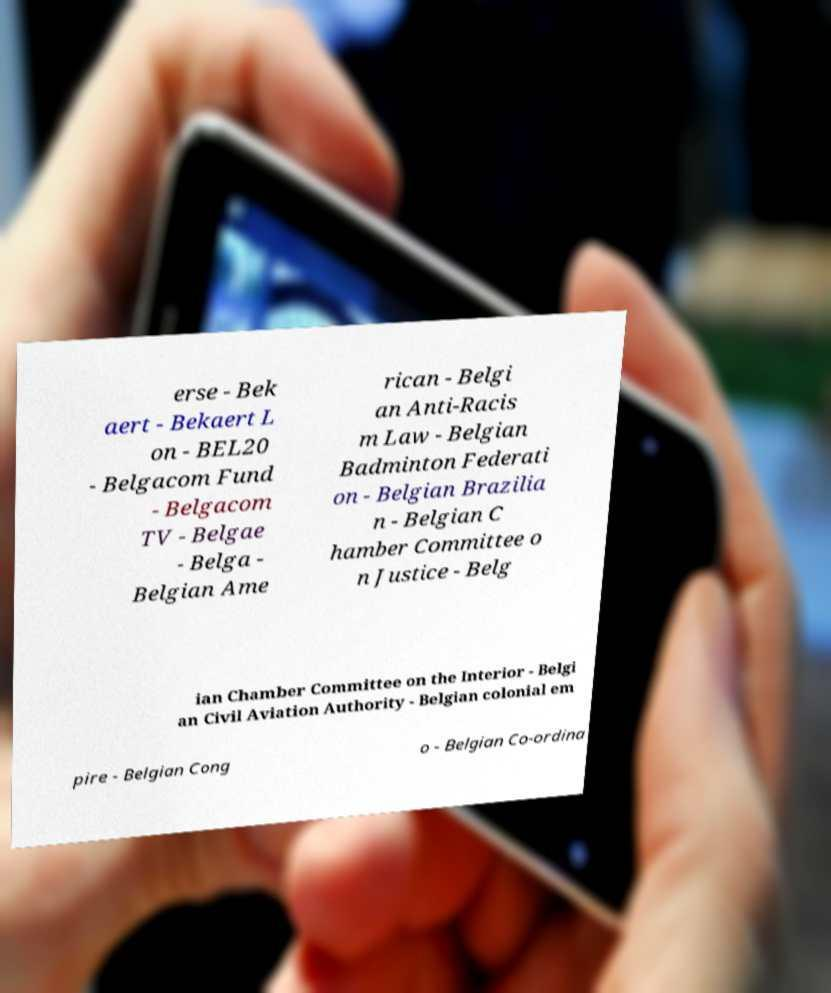Can you read and provide the text displayed in the image?This photo seems to have some interesting text. Can you extract and type it out for me? erse - Bek aert - Bekaert L on - BEL20 - Belgacom Fund - Belgacom TV - Belgae - Belga - Belgian Ame rican - Belgi an Anti-Racis m Law - Belgian Badminton Federati on - Belgian Brazilia n - Belgian C hamber Committee o n Justice - Belg ian Chamber Committee on the Interior - Belgi an Civil Aviation Authority - Belgian colonial em pire - Belgian Cong o - Belgian Co-ordina 